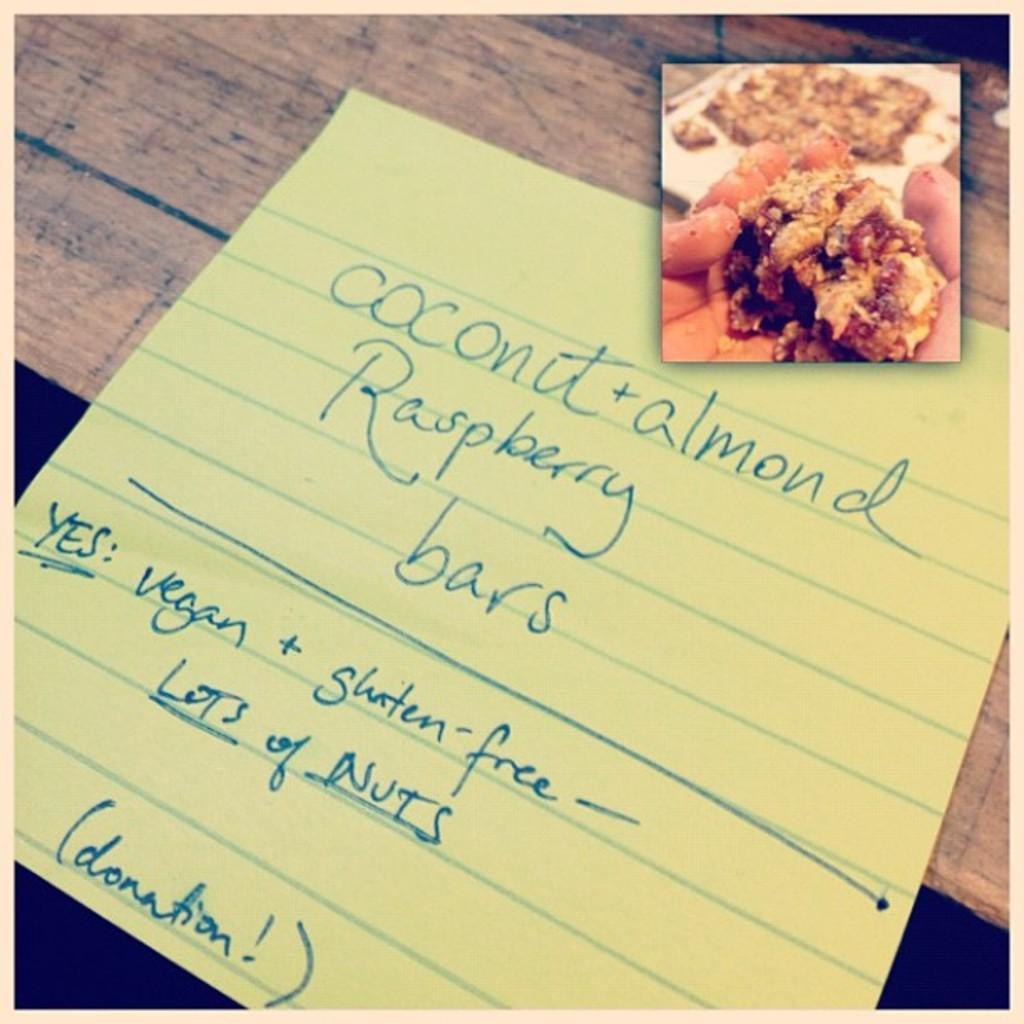Could you give a brief overview of what you see in this image? We can see paper and board on the wooden surface. 